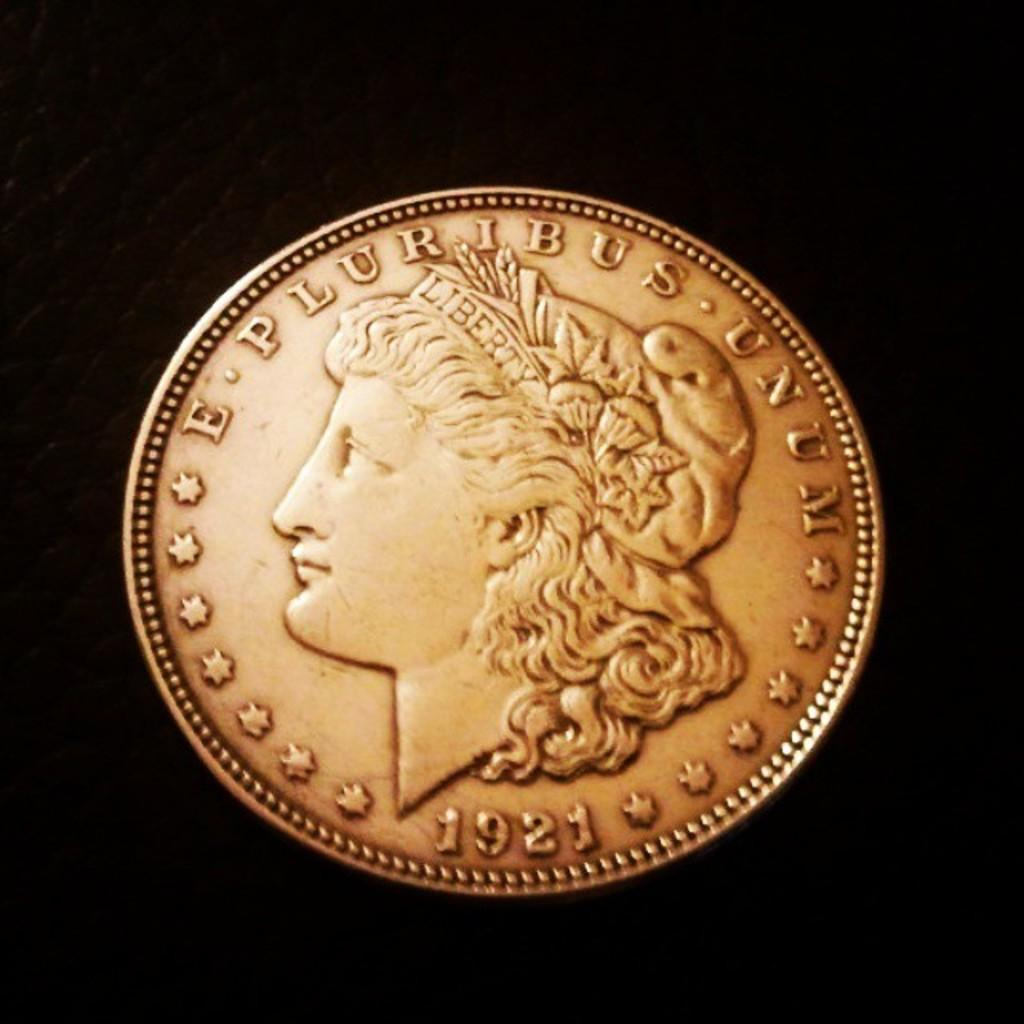<image>
Provide a brief description of the given image. 1921, E Pluribus Unum is etched around the sides of this coin. 